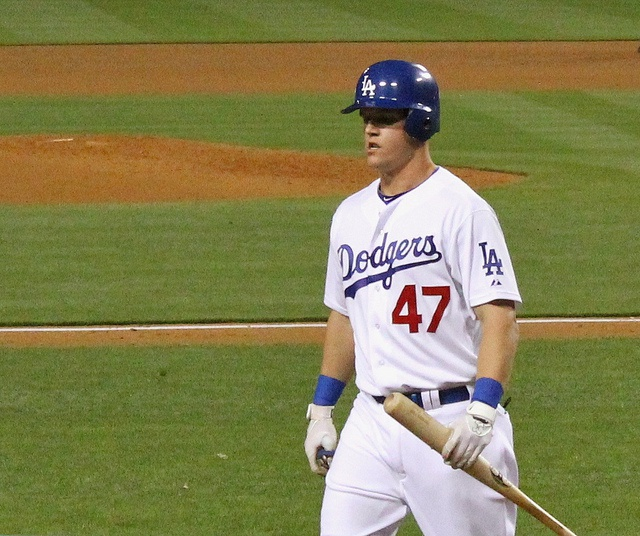Describe the objects in this image and their specific colors. I can see people in olive, lavender, darkgray, and navy tones and baseball bat in olive, tan, and gray tones in this image. 